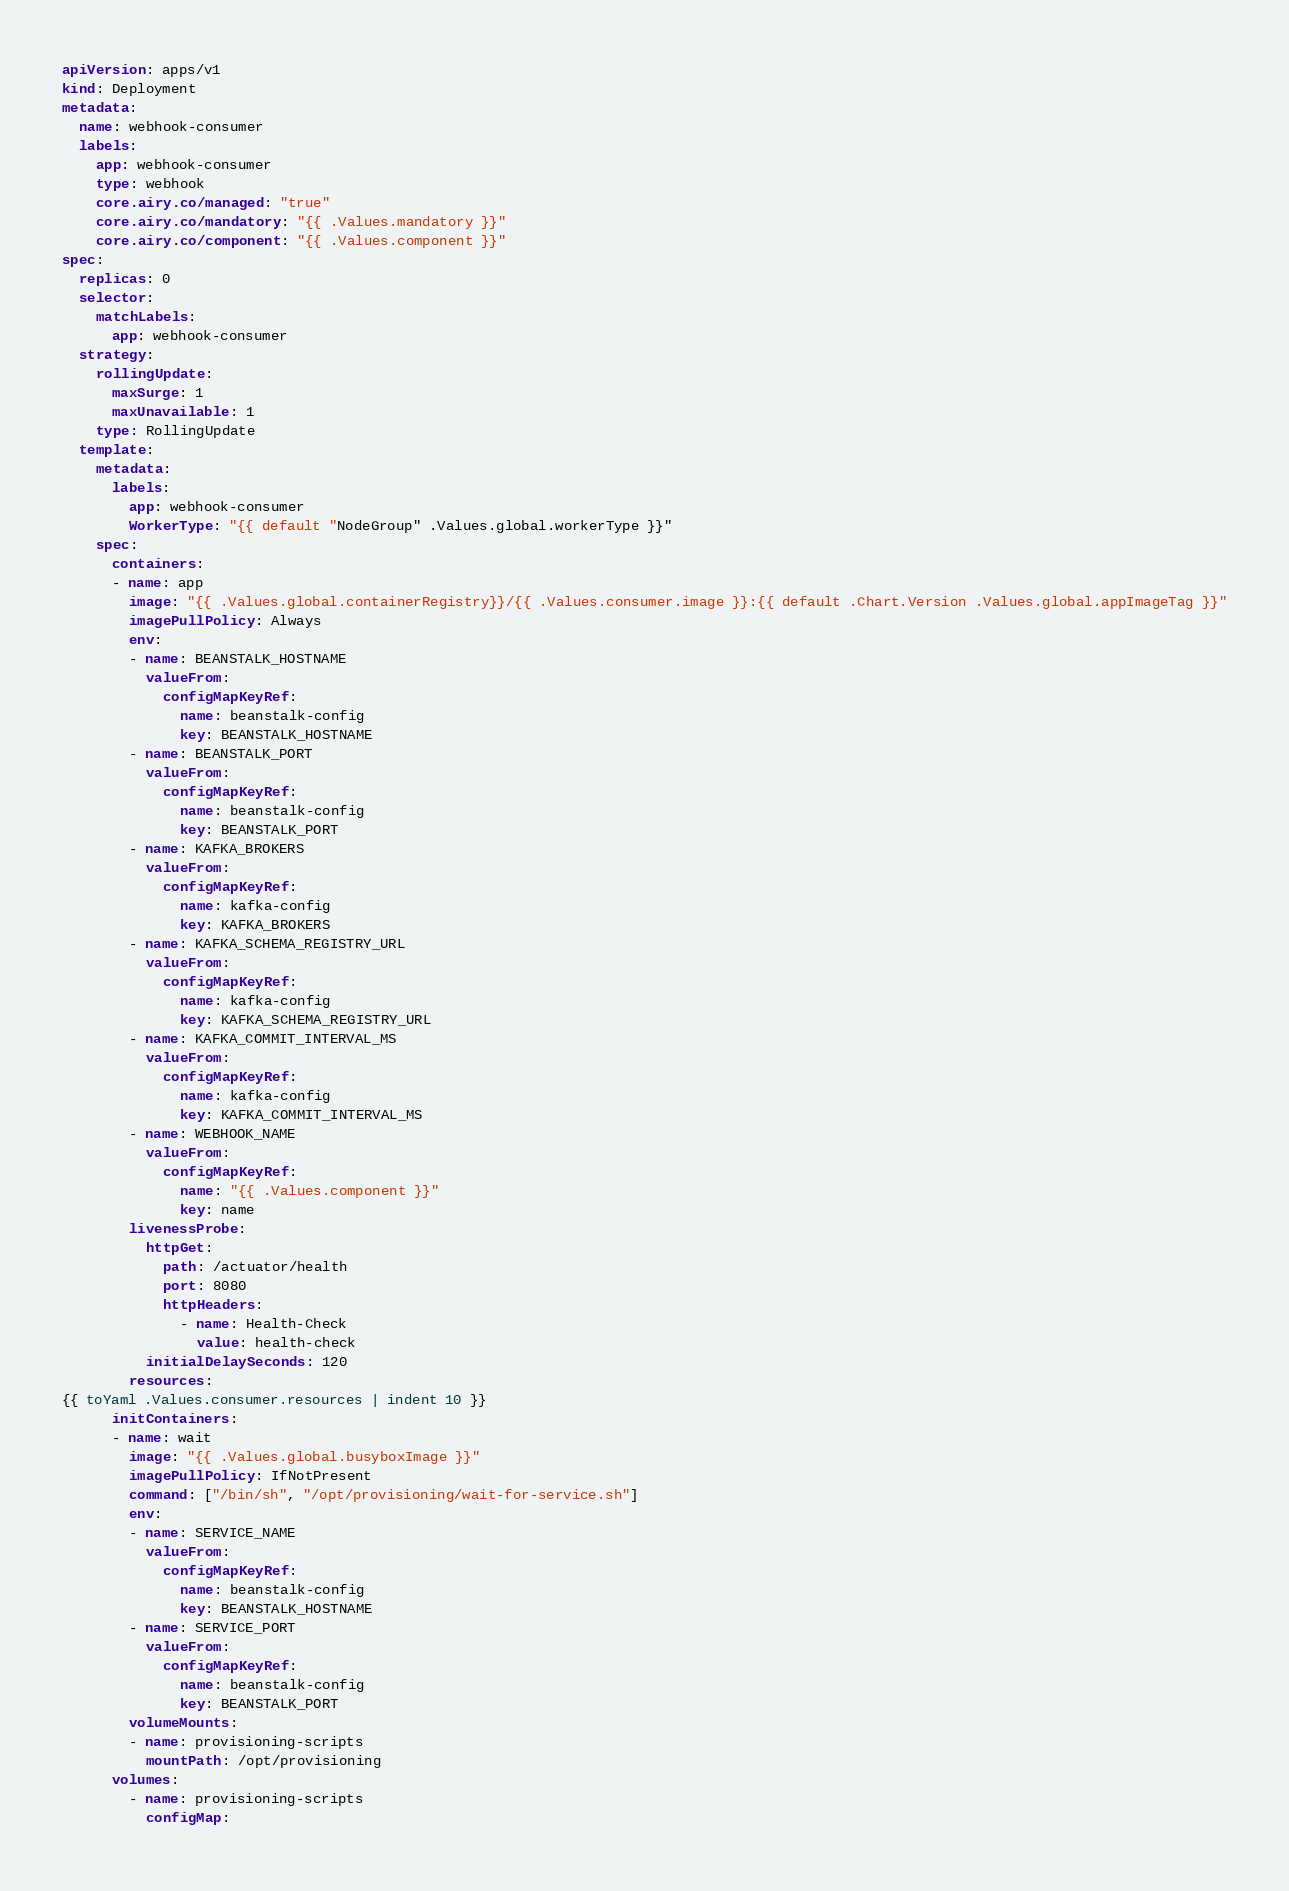<code> <loc_0><loc_0><loc_500><loc_500><_YAML_>apiVersion: apps/v1
kind: Deployment
metadata:
  name: webhook-consumer
  labels:
    app: webhook-consumer
    type: webhook
    core.airy.co/managed: "true"
    core.airy.co/mandatory: "{{ .Values.mandatory }}"
    core.airy.co/component: "{{ .Values.component }}"
spec:
  replicas: 0
  selector:
    matchLabels:
      app: webhook-consumer
  strategy:
    rollingUpdate:
      maxSurge: 1
      maxUnavailable: 1
    type: RollingUpdate
  template:
    metadata:
      labels:
        app: webhook-consumer
        WorkerType: "{{ default "NodeGroup" .Values.global.workerType }}"
    spec:
      containers:
      - name: app
        image: "{{ .Values.global.containerRegistry}}/{{ .Values.consumer.image }}:{{ default .Chart.Version .Values.global.appImageTag }}"
        imagePullPolicy: Always
        env:
        - name: BEANSTALK_HOSTNAME
          valueFrom:
            configMapKeyRef:
              name: beanstalk-config
              key: BEANSTALK_HOSTNAME
        - name: BEANSTALK_PORT
          valueFrom:
            configMapKeyRef:
              name: beanstalk-config
              key: BEANSTALK_PORT
        - name: KAFKA_BROKERS
          valueFrom:
            configMapKeyRef:
              name: kafka-config
              key: KAFKA_BROKERS
        - name: KAFKA_SCHEMA_REGISTRY_URL
          valueFrom:
            configMapKeyRef:
              name: kafka-config
              key: KAFKA_SCHEMA_REGISTRY_URL
        - name: KAFKA_COMMIT_INTERVAL_MS
          valueFrom:
            configMapKeyRef:
              name: kafka-config
              key: KAFKA_COMMIT_INTERVAL_MS
        - name: WEBHOOK_NAME
          valueFrom:
            configMapKeyRef:
              name: "{{ .Values.component }}"
              key: name
        livenessProbe:
          httpGet:
            path: /actuator/health
            port: 8080
            httpHeaders:
              - name: Health-Check
                value: health-check
          initialDelaySeconds: 120
        resources:
{{ toYaml .Values.consumer.resources | indent 10 }}
      initContainers:
      - name: wait
        image: "{{ .Values.global.busyboxImage }}"
        imagePullPolicy: IfNotPresent
        command: ["/bin/sh", "/opt/provisioning/wait-for-service.sh"]
        env:
        - name: SERVICE_NAME
          valueFrom:
            configMapKeyRef:
              name: beanstalk-config
              key: BEANSTALK_HOSTNAME
        - name: SERVICE_PORT
          valueFrom:
            configMapKeyRef:
              name: beanstalk-config
              key: BEANSTALK_PORT
        volumeMounts:
        - name: provisioning-scripts
          mountPath: /opt/provisioning
      volumes:
        - name: provisioning-scripts
          configMap:</code> 